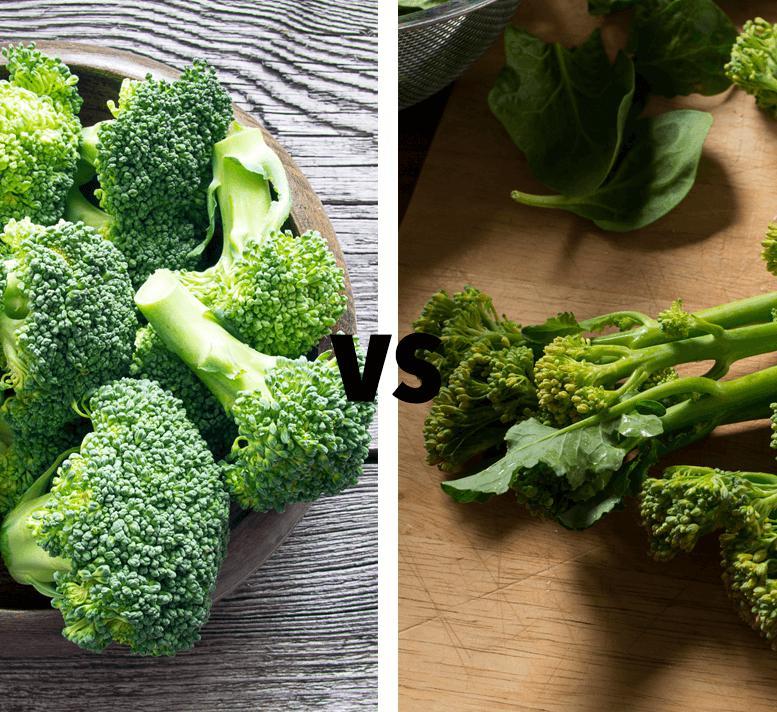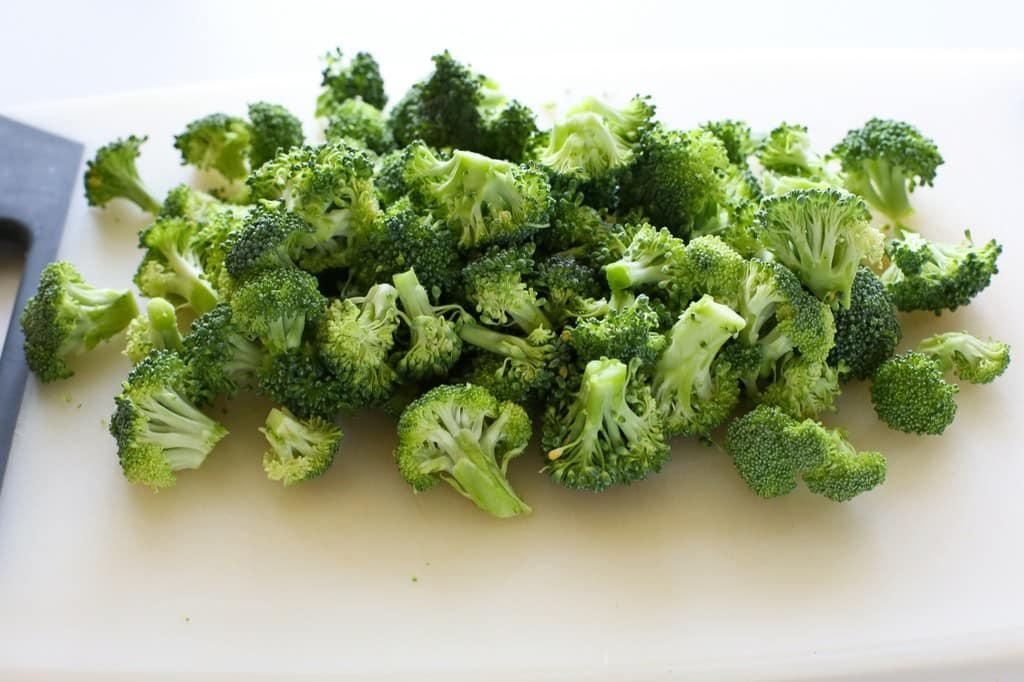The first image is the image on the left, the second image is the image on the right. For the images shown, is this caption "In at least one image there is a total of one full head of lettuce." true? Answer yes or no. No. 